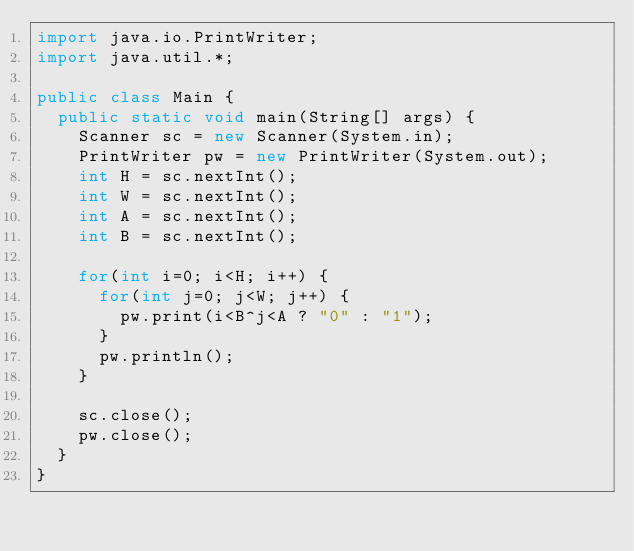Convert code to text. <code><loc_0><loc_0><loc_500><loc_500><_Java_>import java.io.PrintWriter;
import java.util.*;

public class Main {
	public static void main(String[] args) {
		Scanner sc = new Scanner(System.in);
		PrintWriter pw = new PrintWriter(System.out);
		int H = sc.nextInt();
		int W = sc.nextInt();
		int A = sc.nextInt();
		int B = sc.nextInt();
		
		for(int i=0; i<H; i++) {
			for(int j=0; j<W; j++) {
				pw.print(i<B^j<A ? "0" : "1");
			}
			pw.println();
		}
		
		sc.close();
		pw.close();
	}
}
</code> 